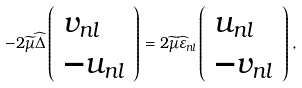<formula> <loc_0><loc_0><loc_500><loc_500>- 2 \widetilde { \mu } \widehat { \Delta } \left ( \begin{array} { l } v _ { n l } \\ - u _ { n l } \end{array} \right ) = 2 \widetilde { \mu } \widehat { \varepsilon } _ { n l } \left ( \begin{array} { l } u _ { n l } \\ - v _ { n l } \end{array} \right ) ,</formula> 